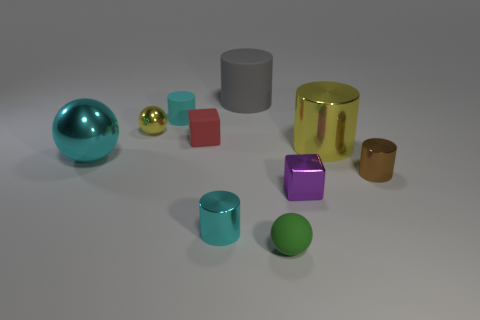What is the material of the big thing to the left of the tiny cube that is behind the brown shiny cylinder?
Offer a terse response. Metal. The tiny object left of the tiny cyan cylinder behind the small yellow metallic object that is in front of the gray rubber object is what shape?
Ensure brevity in your answer.  Sphere. Is the shape of the cyan thing in front of the small brown metallic cylinder the same as the cyan metallic thing to the left of the small yellow metal object?
Keep it short and to the point. No. How many other things are there of the same material as the small red block?
Offer a terse response. 3. What is the shape of the tiny cyan object that is made of the same material as the green thing?
Give a very brief answer. Cylinder. Is the size of the red block the same as the cyan metallic ball?
Keep it short and to the point. No. How big is the yellow shiny object right of the cyan cylinder in front of the big metallic ball?
Provide a short and direct response. Large. There is a big metal object that is the same color as the tiny matte cylinder; what is its shape?
Provide a short and direct response. Sphere. How many spheres are rubber things or tiny purple objects?
Provide a short and direct response. 1. Is the size of the yellow metal ball the same as the yellow thing right of the small green sphere?
Provide a succinct answer. No. 